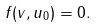Convert formula to latex. <formula><loc_0><loc_0><loc_500><loc_500>f ( v , u _ { 0 } ) = 0 .</formula> 